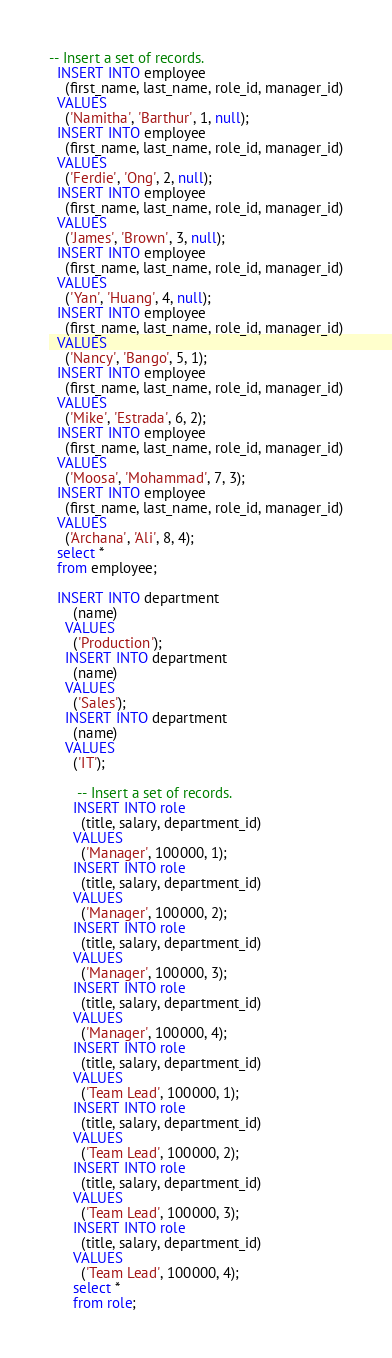Convert code to text. <code><loc_0><loc_0><loc_500><loc_500><_SQL_>-- Insert a set of records.
  INSERT INTO employee
    (first_name, last_name, role_id, manager_id)
  VALUES
    ('Namitha', 'Barthur', 1, null);
  INSERT INTO employee
    (first_name, last_name, role_id, manager_id)
  VALUES
    ('Ferdie', 'Ong', 2, null);
  INSERT INTO employee
    (first_name, last_name, role_id, manager_id)
  VALUES
    ('James', 'Brown', 3, null);
  INSERT INTO employee
    (first_name, last_name, role_id, manager_id)
  VALUES
    ('Yan', 'Huang', 4, null);
  INSERT INTO employee
    (first_name, last_name, role_id, manager_id)
  VALUES
    ('Nancy', 'Bango', 5, 1);
  INSERT INTO employee
    (first_name, last_name, role_id, manager_id)
  VALUES
    ('Mike', 'Estrada', 6, 2);
  INSERT INTO employee
    (first_name, last_name, role_id, manager_id)
  VALUES
    ('Moosa', 'Mohammad', 7, 3);
  INSERT INTO employee
    (first_name, last_name, role_id, manager_id)
  VALUES
    ('Archana', 'Ali', 8, 4);
  select *
  from employee;

  INSERT INTO department
      (name)
    VALUES
      ('Production');
    INSERT INTO department
      (name)
    VALUES
      ('Sales');
    INSERT INTO department
      (name)
    VALUES
      ('IT');

       -- Insert a set of records.
      INSERT INTO role
        (title, salary, department_id)
      VALUES
        ('Manager', 100000, 1);
      INSERT INTO role
        (title, salary, department_id)
      VALUES
        ('Manager', 100000, 2);
      INSERT INTO role
        (title, salary, department_id)
      VALUES
        ('Manager', 100000, 3);
      INSERT INTO role
        (title, salary, department_id)
      VALUES
        ('Manager', 100000, 4);
      INSERT INTO role
        (title, salary, department_id)
      VALUES
        ('Team Lead', 100000, 1);
      INSERT INTO role
        (title, salary, department_id)
      VALUES
        ('Team Lead', 100000, 2);
      INSERT INTO role
        (title, salary, department_id)
      VALUES
        ('Team Lead', 100000, 3);
      INSERT INTO role
        (title, salary, department_id)
      VALUES
        ('Team Lead', 100000, 4);
      select *
      from role;
</code> 